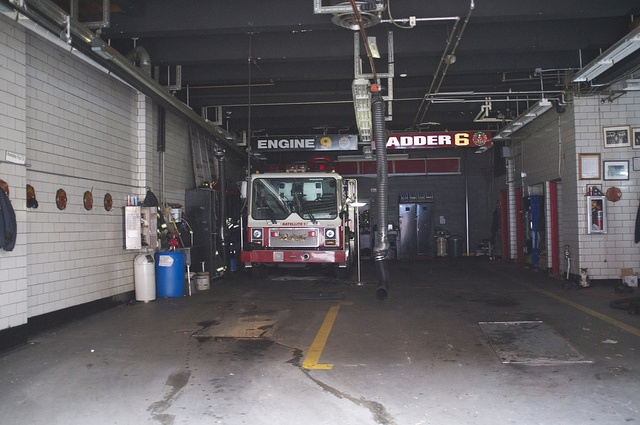Describe the objects in this image and their specific colors. I can see a truck in black, gray, darkgray, and lightgray tones in this image. 